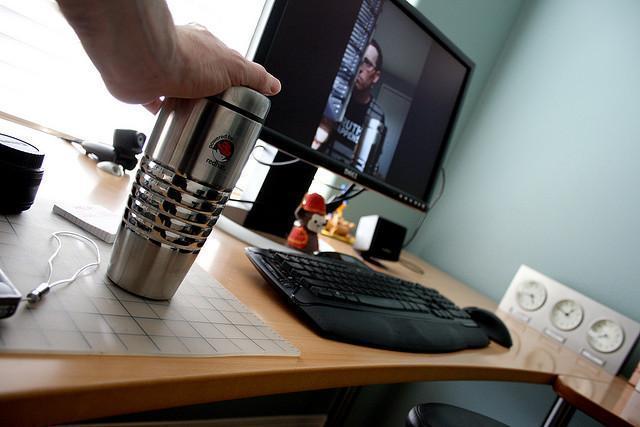How many people are in the photo?
Give a very brief answer. 2. 